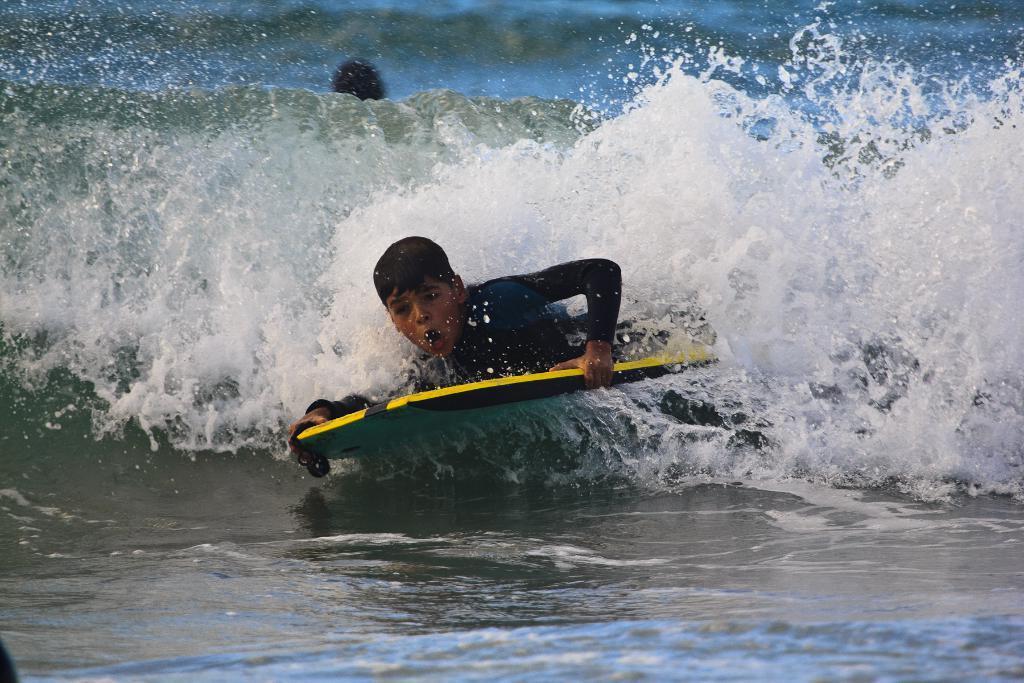In one or two sentences, can you explain what this image depicts? This is a picture taken in the outdoors. The boy is holding a board and surfing on water. Behind the boy there is other person. 